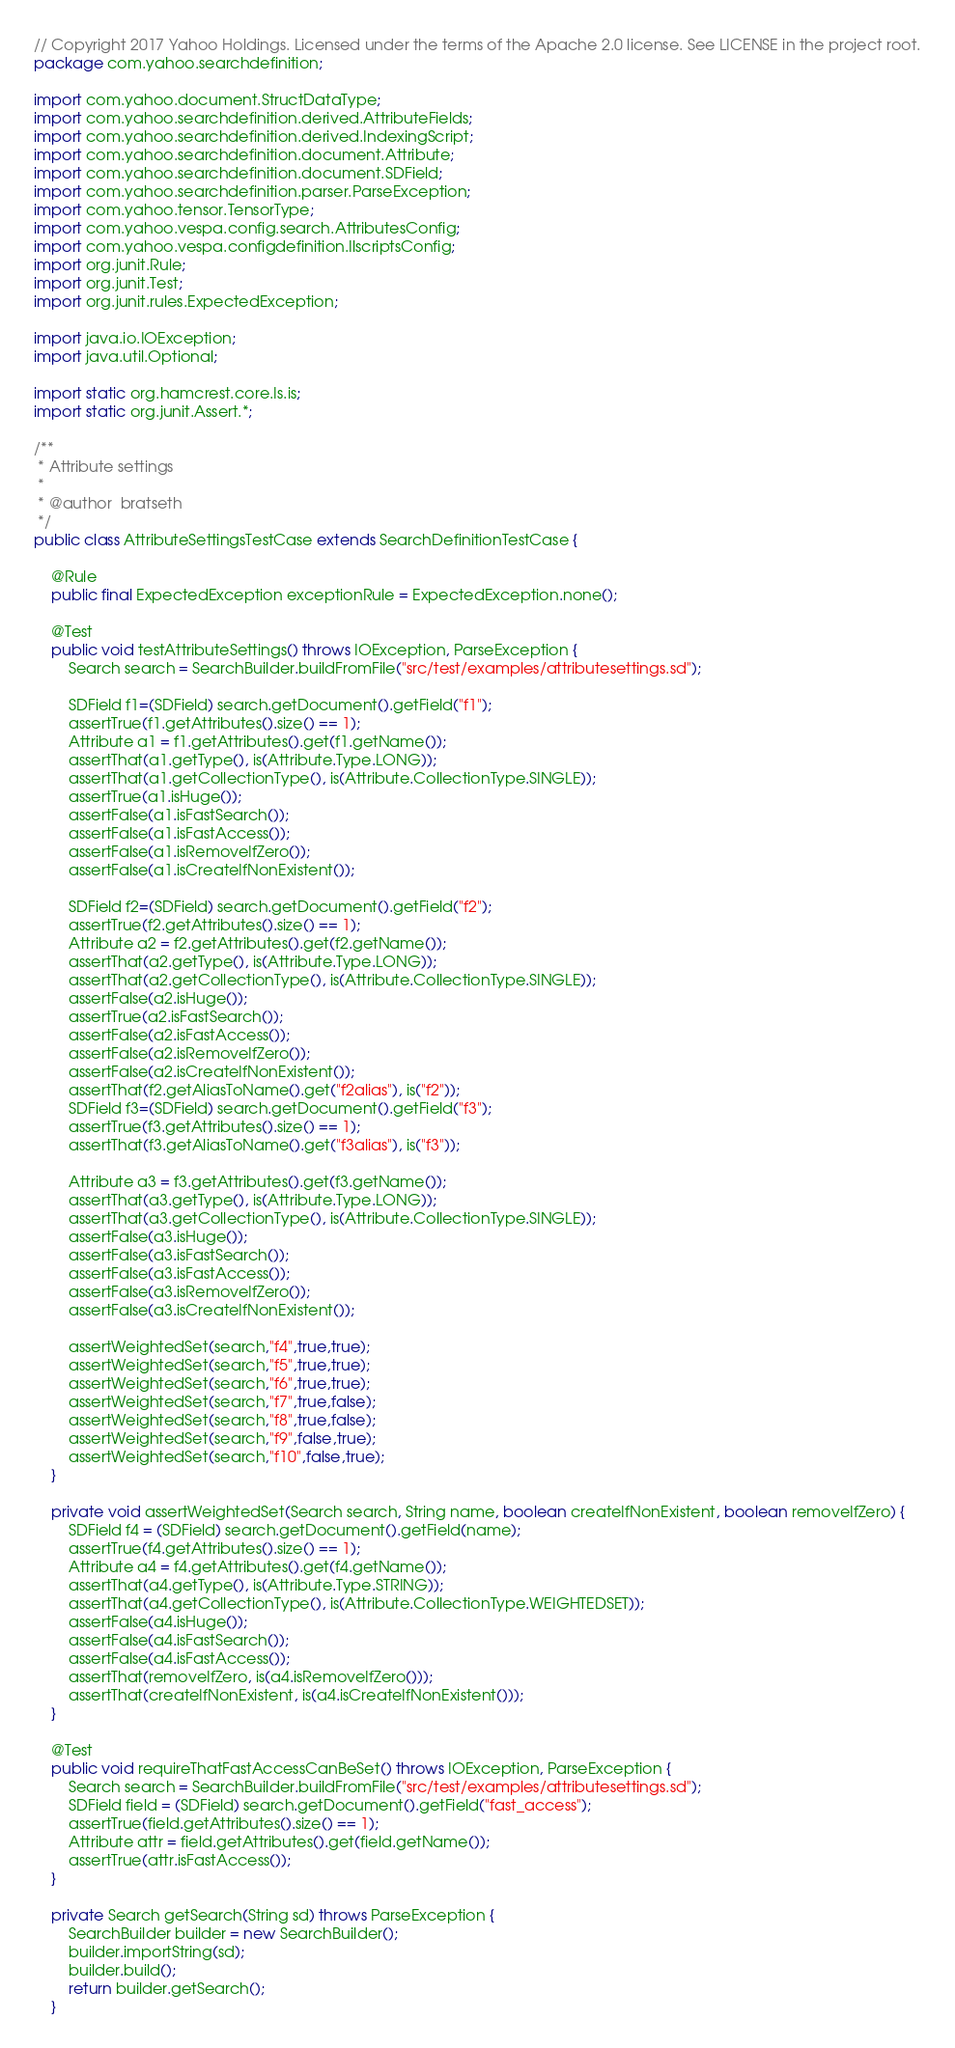Convert code to text. <code><loc_0><loc_0><loc_500><loc_500><_Java_>// Copyright 2017 Yahoo Holdings. Licensed under the terms of the Apache 2.0 license. See LICENSE in the project root.
package com.yahoo.searchdefinition;

import com.yahoo.document.StructDataType;
import com.yahoo.searchdefinition.derived.AttributeFields;
import com.yahoo.searchdefinition.derived.IndexingScript;
import com.yahoo.searchdefinition.document.Attribute;
import com.yahoo.searchdefinition.document.SDField;
import com.yahoo.searchdefinition.parser.ParseException;
import com.yahoo.tensor.TensorType;
import com.yahoo.vespa.config.search.AttributesConfig;
import com.yahoo.vespa.configdefinition.IlscriptsConfig;
import org.junit.Rule;
import org.junit.Test;
import org.junit.rules.ExpectedException;

import java.io.IOException;
import java.util.Optional;

import static org.hamcrest.core.Is.is;
import static org.junit.Assert.*;

/**
 * Attribute settings
 *
 * @author  bratseth
 */
public class AttributeSettingsTestCase extends SearchDefinitionTestCase {

    @Rule
    public final ExpectedException exceptionRule = ExpectedException.none();

    @Test
    public void testAttributeSettings() throws IOException, ParseException {
        Search search = SearchBuilder.buildFromFile("src/test/examples/attributesettings.sd");

        SDField f1=(SDField) search.getDocument().getField("f1");
        assertTrue(f1.getAttributes().size() == 1);
        Attribute a1 = f1.getAttributes().get(f1.getName());
        assertThat(a1.getType(), is(Attribute.Type.LONG));
        assertThat(a1.getCollectionType(), is(Attribute.CollectionType.SINGLE));
        assertTrue(a1.isHuge());
        assertFalse(a1.isFastSearch());
        assertFalse(a1.isFastAccess());
        assertFalse(a1.isRemoveIfZero());
        assertFalse(a1.isCreateIfNonExistent());

        SDField f2=(SDField) search.getDocument().getField("f2");
        assertTrue(f2.getAttributes().size() == 1);
        Attribute a2 = f2.getAttributes().get(f2.getName());
        assertThat(a2.getType(), is(Attribute.Type.LONG));
        assertThat(a2.getCollectionType(), is(Attribute.CollectionType.SINGLE));
        assertFalse(a2.isHuge());
        assertTrue(a2.isFastSearch());
        assertFalse(a2.isFastAccess());
        assertFalse(a2.isRemoveIfZero());
        assertFalse(a2.isCreateIfNonExistent());
        assertThat(f2.getAliasToName().get("f2alias"), is("f2"));
        SDField f3=(SDField) search.getDocument().getField("f3");
        assertTrue(f3.getAttributes().size() == 1);
        assertThat(f3.getAliasToName().get("f3alias"), is("f3"));

        Attribute a3 = f3.getAttributes().get(f3.getName());
        assertThat(a3.getType(), is(Attribute.Type.LONG));
        assertThat(a3.getCollectionType(), is(Attribute.CollectionType.SINGLE));
        assertFalse(a3.isHuge());
        assertFalse(a3.isFastSearch());
        assertFalse(a3.isFastAccess());
        assertFalse(a3.isRemoveIfZero());
        assertFalse(a3.isCreateIfNonExistent());

        assertWeightedSet(search,"f4",true,true);
        assertWeightedSet(search,"f5",true,true);
        assertWeightedSet(search,"f6",true,true);
        assertWeightedSet(search,"f7",true,false);
        assertWeightedSet(search,"f8",true,false);
        assertWeightedSet(search,"f9",false,true);
        assertWeightedSet(search,"f10",false,true);
    }

    private void assertWeightedSet(Search search, String name, boolean createIfNonExistent, boolean removeIfZero) {
        SDField f4 = (SDField) search.getDocument().getField(name);
        assertTrue(f4.getAttributes().size() == 1);
        Attribute a4 = f4.getAttributes().get(f4.getName());
        assertThat(a4.getType(), is(Attribute.Type.STRING));
        assertThat(a4.getCollectionType(), is(Attribute.CollectionType.WEIGHTEDSET));
        assertFalse(a4.isHuge());
        assertFalse(a4.isFastSearch());
        assertFalse(a4.isFastAccess());
        assertThat(removeIfZero, is(a4.isRemoveIfZero()));
        assertThat(createIfNonExistent, is(a4.isCreateIfNonExistent()));
    }

    @Test
    public void requireThatFastAccessCanBeSet() throws IOException, ParseException {
        Search search = SearchBuilder.buildFromFile("src/test/examples/attributesettings.sd");
        SDField field = (SDField) search.getDocument().getField("fast_access");
        assertTrue(field.getAttributes().size() == 1);
        Attribute attr = field.getAttributes().get(field.getName());
        assertTrue(attr.isFastAccess());
    }

    private Search getSearch(String sd) throws ParseException {
        SearchBuilder builder = new SearchBuilder();
        builder.importString(sd);
        builder.build();
        return builder.getSearch();
    }
</code> 